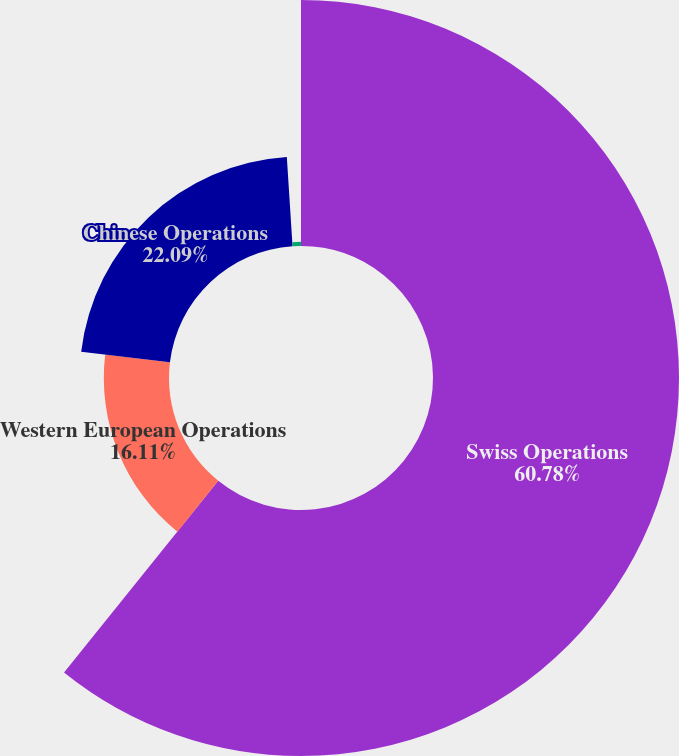Convert chart to OTSL. <chart><loc_0><loc_0><loc_500><loc_500><pie_chart><fcel>Swiss Operations<fcel>Western European Operations<fcel>Chinese Operations<fcel>Other^(a)<nl><fcel>60.79%<fcel>16.11%<fcel>22.09%<fcel>1.02%<nl></chart> 